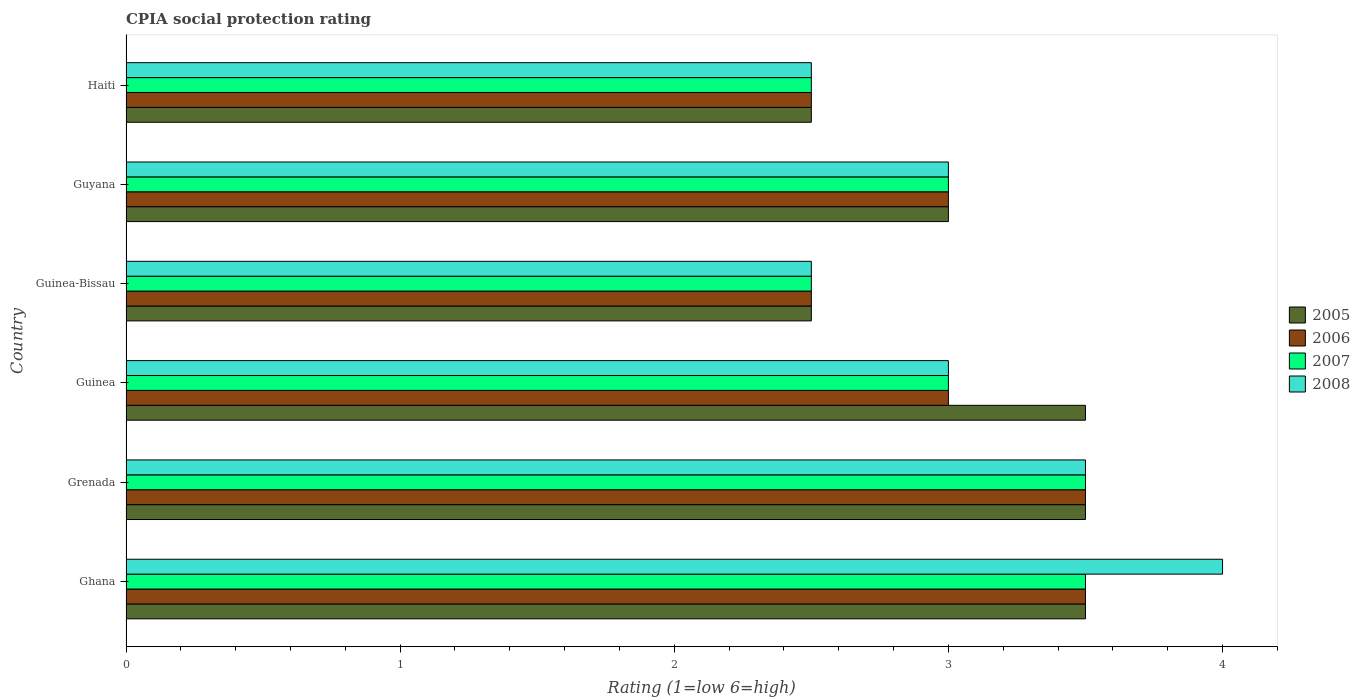How many different coloured bars are there?
Offer a very short reply. 4. How many groups of bars are there?
Your response must be concise. 6. Are the number of bars on each tick of the Y-axis equal?
Keep it short and to the point. Yes. How many bars are there on the 2nd tick from the top?
Your response must be concise. 4. How many bars are there on the 5th tick from the bottom?
Ensure brevity in your answer.  4. What is the label of the 4th group of bars from the top?
Keep it short and to the point. Guinea. What is the CPIA rating in 2005 in Guinea-Bissau?
Provide a succinct answer. 2.5. In which country was the CPIA rating in 2006 maximum?
Ensure brevity in your answer.  Ghana. In which country was the CPIA rating in 2007 minimum?
Keep it short and to the point. Guinea-Bissau. What is the difference between the CPIA rating in 2008 and CPIA rating in 2006 in Guinea?
Ensure brevity in your answer.  0. What is the ratio of the CPIA rating in 2006 in Ghana to that in Guinea?
Ensure brevity in your answer.  1.17. Is the CPIA rating in 2005 in Guinea less than that in Guyana?
Provide a succinct answer. No. Is the difference between the CPIA rating in 2008 in Grenada and Haiti greater than the difference between the CPIA rating in 2006 in Grenada and Haiti?
Your response must be concise. No. What is the difference between the highest and the second highest CPIA rating in 2005?
Your answer should be very brief. 0. What is the difference between the highest and the lowest CPIA rating in 2005?
Ensure brevity in your answer.  1. In how many countries, is the CPIA rating in 2005 greater than the average CPIA rating in 2005 taken over all countries?
Your answer should be compact. 3. Is the sum of the CPIA rating in 2008 in Guinea and Guinea-Bissau greater than the maximum CPIA rating in 2007 across all countries?
Your answer should be compact. Yes. What does the 1st bar from the top in Grenada represents?
Offer a terse response. 2008. How many bars are there?
Your answer should be very brief. 24. Are all the bars in the graph horizontal?
Your answer should be compact. Yes. Are the values on the major ticks of X-axis written in scientific E-notation?
Make the answer very short. No. Does the graph contain any zero values?
Your answer should be compact. No. Where does the legend appear in the graph?
Keep it short and to the point. Center right. What is the title of the graph?
Your answer should be compact. CPIA social protection rating. What is the label or title of the X-axis?
Ensure brevity in your answer.  Rating (1=low 6=high). What is the label or title of the Y-axis?
Ensure brevity in your answer.  Country. What is the Rating (1=low 6=high) of 2005 in Ghana?
Your answer should be compact. 3.5. What is the Rating (1=low 6=high) in 2006 in Ghana?
Provide a short and direct response. 3.5. What is the Rating (1=low 6=high) in 2006 in Grenada?
Provide a short and direct response. 3.5. What is the Rating (1=low 6=high) of 2008 in Grenada?
Your response must be concise. 3.5. What is the Rating (1=low 6=high) in 2005 in Guinea?
Your answer should be compact. 3.5. What is the Rating (1=low 6=high) of 2007 in Guinea?
Make the answer very short. 3. What is the Rating (1=low 6=high) in 2005 in Guinea-Bissau?
Make the answer very short. 2.5. What is the Rating (1=low 6=high) in 2007 in Guinea-Bissau?
Keep it short and to the point. 2.5. What is the Rating (1=low 6=high) of 2008 in Guinea-Bissau?
Give a very brief answer. 2.5. What is the Rating (1=low 6=high) in 2005 in Guyana?
Your answer should be compact. 3. What is the Rating (1=low 6=high) of 2006 in Haiti?
Give a very brief answer. 2.5. What is the Rating (1=low 6=high) of 2007 in Haiti?
Provide a short and direct response. 2.5. What is the Rating (1=low 6=high) of 2008 in Haiti?
Ensure brevity in your answer.  2.5. Across all countries, what is the maximum Rating (1=low 6=high) of 2005?
Make the answer very short. 3.5. Across all countries, what is the maximum Rating (1=low 6=high) of 2007?
Your answer should be compact. 3.5. Across all countries, what is the maximum Rating (1=low 6=high) of 2008?
Your response must be concise. 4. Across all countries, what is the minimum Rating (1=low 6=high) in 2005?
Ensure brevity in your answer.  2.5. Across all countries, what is the minimum Rating (1=low 6=high) in 2007?
Your response must be concise. 2.5. Across all countries, what is the minimum Rating (1=low 6=high) of 2008?
Offer a terse response. 2.5. What is the difference between the Rating (1=low 6=high) in 2005 in Ghana and that in Grenada?
Give a very brief answer. 0. What is the difference between the Rating (1=low 6=high) in 2007 in Ghana and that in Grenada?
Ensure brevity in your answer.  0. What is the difference between the Rating (1=low 6=high) in 2005 in Ghana and that in Guinea?
Keep it short and to the point. 0. What is the difference between the Rating (1=low 6=high) in 2008 in Ghana and that in Guinea?
Your answer should be very brief. 1. What is the difference between the Rating (1=low 6=high) of 2006 in Ghana and that in Guyana?
Ensure brevity in your answer.  0.5. What is the difference between the Rating (1=low 6=high) of 2005 in Ghana and that in Haiti?
Provide a short and direct response. 1. What is the difference between the Rating (1=low 6=high) of 2006 in Ghana and that in Haiti?
Your answer should be compact. 1. What is the difference between the Rating (1=low 6=high) in 2006 in Grenada and that in Guinea?
Your answer should be compact. 0.5. What is the difference between the Rating (1=low 6=high) of 2008 in Grenada and that in Guinea?
Keep it short and to the point. 0.5. What is the difference between the Rating (1=low 6=high) in 2008 in Grenada and that in Guinea-Bissau?
Keep it short and to the point. 1. What is the difference between the Rating (1=low 6=high) of 2006 in Grenada and that in Guyana?
Your answer should be very brief. 0.5. What is the difference between the Rating (1=low 6=high) in 2006 in Grenada and that in Haiti?
Your answer should be compact. 1. What is the difference between the Rating (1=low 6=high) in 2007 in Grenada and that in Haiti?
Offer a terse response. 1. What is the difference between the Rating (1=low 6=high) of 2007 in Guinea and that in Guinea-Bissau?
Offer a terse response. 0.5. What is the difference between the Rating (1=low 6=high) of 2007 in Guinea and that in Guyana?
Ensure brevity in your answer.  0. What is the difference between the Rating (1=low 6=high) in 2008 in Guinea and that in Guyana?
Offer a terse response. 0. What is the difference between the Rating (1=low 6=high) in 2005 in Guinea and that in Haiti?
Your answer should be very brief. 1. What is the difference between the Rating (1=low 6=high) in 2007 in Guinea and that in Haiti?
Offer a terse response. 0.5. What is the difference between the Rating (1=low 6=high) of 2005 in Guinea-Bissau and that in Guyana?
Provide a short and direct response. -0.5. What is the difference between the Rating (1=low 6=high) in 2007 in Guinea-Bissau and that in Guyana?
Ensure brevity in your answer.  -0.5. What is the difference between the Rating (1=low 6=high) of 2005 in Guinea-Bissau and that in Haiti?
Offer a terse response. 0. What is the difference between the Rating (1=low 6=high) of 2007 in Guinea-Bissau and that in Haiti?
Provide a succinct answer. 0. What is the difference between the Rating (1=low 6=high) of 2007 in Guyana and that in Haiti?
Keep it short and to the point. 0.5. What is the difference between the Rating (1=low 6=high) in 2008 in Guyana and that in Haiti?
Offer a terse response. 0.5. What is the difference between the Rating (1=low 6=high) in 2005 in Ghana and the Rating (1=low 6=high) in 2007 in Grenada?
Keep it short and to the point. 0. What is the difference between the Rating (1=low 6=high) of 2006 in Ghana and the Rating (1=low 6=high) of 2007 in Grenada?
Your answer should be compact. 0. What is the difference between the Rating (1=low 6=high) of 2007 in Ghana and the Rating (1=low 6=high) of 2008 in Grenada?
Keep it short and to the point. 0. What is the difference between the Rating (1=low 6=high) of 2005 in Ghana and the Rating (1=low 6=high) of 2007 in Guinea?
Offer a very short reply. 0.5. What is the difference between the Rating (1=low 6=high) in 2005 in Ghana and the Rating (1=low 6=high) in 2008 in Guinea?
Your answer should be very brief. 0.5. What is the difference between the Rating (1=low 6=high) in 2007 in Ghana and the Rating (1=low 6=high) in 2008 in Guinea?
Provide a succinct answer. 0.5. What is the difference between the Rating (1=low 6=high) in 2006 in Ghana and the Rating (1=low 6=high) in 2007 in Guinea-Bissau?
Provide a short and direct response. 1. What is the difference between the Rating (1=low 6=high) of 2006 in Ghana and the Rating (1=low 6=high) of 2008 in Guinea-Bissau?
Provide a short and direct response. 1. What is the difference between the Rating (1=low 6=high) in 2007 in Ghana and the Rating (1=low 6=high) in 2008 in Guinea-Bissau?
Provide a succinct answer. 1. What is the difference between the Rating (1=low 6=high) in 2006 in Ghana and the Rating (1=low 6=high) in 2008 in Guyana?
Your answer should be compact. 0.5. What is the difference between the Rating (1=low 6=high) of 2007 in Ghana and the Rating (1=low 6=high) of 2008 in Guyana?
Keep it short and to the point. 0.5. What is the difference between the Rating (1=low 6=high) of 2005 in Ghana and the Rating (1=low 6=high) of 2006 in Haiti?
Your answer should be compact. 1. What is the difference between the Rating (1=low 6=high) in 2005 in Ghana and the Rating (1=low 6=high) in 2008 in Haiti?
Ensure brevity in your answer.  1. What is the difference between the Rating (1=low 6=high) of 2005 in Grenada and the Rating (1=low 6=high) of 2006 in Guinea?
Your answer should be compact. 0.5. What is the difference between the Rating (1=low 6=high) of 2007 in Grenada and the Rating (1=low 6=high) of 2008 in Guinea?
Offer a terse response. 0.5. What is the difference between the Rating (1=low 6=high) in 2005 in Grenada and the Rating (1=low 6=high) in 2006 in Guinea-Bissau?
Provide a succinct answer. 1. What is the difference between the Rating (1=low 6=high) in 2005 in Grenada and the Rating (1=low 6=high) in 2008 in Guinea-Bissau?
Keep it short and to the point. 1. What is the difference between the Rating (1=low 6=high) in 2006 in Grenada and the Rating (1=low 6=high) in 2008 in Guinea-Bissau?
Ensure brevity in your answer.  1. What is the difference between the Rating (1=low 6=high) of 2005 in Grenada and the Rating (1=low 6=high) of 2006 in Guyana?
Keep it short and to the point. 0.5. What is the difference between the Rating (1=low 6=high) of 2005 in Grenada and the Rating (1=low 6=high) of 2007 in Guyana?
Give a very brief answer. 0.5. What is the difference between the Rating (1=low 6=high) in 2006 in Grenada and the Rating (1=low 6=high) in 2008 in Guyana?
Your answer should be very brief. 0.5. What is the difference between the Rating (1=low 6=high) of 2005 in Grenada and the Rating (1=low 6=high) of 2006 in Haiti?
Make the answer very short. 1. What is the difference between the Rating (1=low 6=high) of 2005 in Grenada and the Rating (1=low 6=high) of 2008 in Haiti?
Offer a very short reply. 1. What is the difference between the Rating (1=low 6=high) in 2006 in Grenada and the Rating (1=low 6=high) in 2008 in Haiti?
Ensure brevity in your answer.  1. What is the difference between the Rating (1=low 6=high) of 2007 in Grenada and the Rating (1=low 6=high) of 2008 in Haiti?
Your answer should be compact. 1. What is the difference between the Rating (1=low 6=high) in 2005 in Guinea and the Rating (1=low 6=high) in 2006 in Guinea-Bissau?
Provide a short and direct response. 1. What is the difference between the Rating (1=low 6=high) in 2005 in Guinea and the Rating (1=low 6=high) in 2008 in Guinea-Bissau?
Provide a short and direct response. 1. What is the difference between the Rating (1=low 6=high) in 2006 in Guinea and the Rating (1=low 6=high) in 2008 in Guinea-Bissau?
Your answer should be compact. 0.5. What is the difference between the Rating (1=low 6=high) in 2005 in Guinea and the Rating (1=low 6=high) in 2006 in Guyana?
Keep it short and to the point. 0.5. What is the difference between the Rating (1=low 6=high) in 2005 in Guinea and the Rating (1=low 6=high) in 2007 in Guyana?
Offer a terse response. 0.5. What is the difference between the Rating (1=low 6=high) of 2006 in Guinea and the Rating (1=low 6=high) of 2008 in Guyana?
Ensure brevity in your answer.  0. What is the difference between the Rating (1=low 6=high) of 2007 in Guinea and the Rating (1=low 6=high) of 2008 in Guyana?
Give a very brief answer. 0. What is the difference between the Rating (1=low 6=high) in 2005 in Guinea and the Rating (1=low 6=high) in 2006 in Haiti?
Offer a very short reply. 1. What is the difference between the Rating (1=low 6=high) in 2005 in Guinea and the Rating (1=low 6=high) in 2007 in Haiti?
Give a very brief answer. 1. What is the difference between the Rating (1=low 6=high) of 2006 in Guinea and the Rating (1=low 6=high) of 2007 in Haiti?
Offer a very short reply. 0.5. What is the difference between the Rating (1=low 6=high) of 2007 in Guinea and the Rating (1=low 6=high) of 2008 in Haiti?
Provide a short and direct response. 0.5. What is the difference between the Rating (1=low 6=high) in 2005 in Guinea-Bissau and the Rating (1=low 6=high) in 2007 in Guyana?
Your answer should be very brief. -0.5. What is the difference between the Rating (1=low 6=high) in 2005 in Guinea-Bissau and the Rating (1=low 6=high) in 2006 in Haiti?
Provide a succinct answer. 0. What is the difference between the Rating (1=low 6=high) in 2005 in Guyana and the Rating (1=low 6=high) in 2007 in Haiti?
Provide a succinct answer. 0.5. What is the difference between the Rating (1=low 6=high) in 2005 in Guyana and the Rating (1=low 6=high) in 2008 in Haiti?
Your answer should be compact. 0.5. What is the difference between the Rating (1=low 6=high) of 2006 in Guyana and the Rating (1=low 6=high) of 2007 in Haiti?
Provide a succinct answer. 0.5. What is the average Rating (1=low 6=high) of 2005 per country?
Ensure brevity in your answer.  3.08. What is the average Rating (1=low 6=high) in 2008 per country?
Provide a short and direct response. 3.08. What is the difference between the Rating (1=low 6=high) in 2005 and Rating (1=low 6=high) in 2007 in Ghana?
Your response must be concise. 0. What is the difference between the Rating (1=low 6=high) in 2005 and Rating (1=low 6=high) in 2008 in Ghana?
Your answer should be compact. -0.5. What is the difference between the Rating (1=low 6=high) in 2006 and Rating (1=low 6=high) in 2007 in Ghana?
Offer a terse response. 0. What is the difference between the Rating (1=low 6=high) in 2007 and Rating (1=low 6=high) in 2008 in Ghana?
Provide a succinct answer. -0.5. What is the difference between the Rating (1=low 6=high) of 2005 and Rating (1=low 6=high) of 2008 in Grenada?
Ensure brevity in your answer.  0. What is the difference between the Rating (1=low 6=high) of 2006 and Rating (1=low 6=high) of 2007 in Grenada?
Offer a terse response. 0. What is the difference between the Rating (1=low 6=high) of 2007 and Rating (1=low 6=high) of 2008 in Grenada?
Provide a short and direct response. 0. What is the difference between the Rating (1=low 6=high) in 2005 and Rating (1=low 6=high) in 2008 in Guinea?
Keep it short and to the point. 0.5. What is the difference between the Rating (1=low 6=high) in 2006 and Rating (1=low 6=high) in 2007 in Guinea?
Provide a succinct answer. 0. What is the difference between the Rating (1=low 6=high) in 2006 and Rating (1=low 6=high) in 2007 in Guinea-Bissau?
Keep it short and to the point. 0. What is the difference between the Rating (1=low 6=high) in 2005 and Rating (1=low 6=high) in 2007 in Guyana?
Your answer should be very brief. 0. What is the difference between the Rating (1=low 6=high) of 2006 and Rating (1=low 6=high) of 2007 in Guyana?
Keep it short and to the point. 0. What is the difference between the Rating (1=low 6=high) of 2006 and Rating (1=low 6=high) of 2008 in Guyana?
Provide a short and direct response. 0. What is the difference between the Rating (1=low 6=high) in 2005 and Rating (1=low 6=high) in 2006 in Haiti?
Provide a short and direct response. 0. What is the difference between the Rating (1=low 6=high) of 2005 and Rating (1=low 6=high) of 2008 in Haiti?
Your answer should be very brief. 0. What is the difference between the Rating (1=low 6=high) in 2006 and Rating (1=low 6=high) in 2008 in Haiti?
Your response must be concise. 0. What is the ratio of the Rating (1=low 6=high) in 2006 in Ghana to that in Grenada?
Give a very brief answer. 1. What is the ratio of the Rating (1=low 6=high) in 2008 in Ghana to that in Grenada?
Provide a short and direct response. 1.14. What is the ratio of the Rating (1=low 6=high) of 2005 in Ghana to that in Guinea?
Offer a very short reply. 1. What is the ratio of the Rating (1=low 6=high) of 2006 in Ghana to that in Guinea?
Offer a terse response. 1.17. What is the ratio of the Rating (1=low 6=high) in 2007 in Ghana to that in Guinea?
Make the answer very short. 1.17. What is the ratio of the Rating (1=low 6=high) in 2008 in Ghana to that in Guinea?
Offer a very short reply. 1.33. What is the ratio of the Rating (1=low 6=high) in 2005 in Ghana to that in Guinea-Bissau?
Offer a terse response. 1.4. What is the ratio of the Rating (1=low 6=high) in 2005 in Ghana to that in Guyana?
Ensure brevity in your answer.  1.17. What is the ratio of the Rating (1=low 6=high) of 2008 in Ghana to that in Guyana?
Offer a terse response. 1.33. What is the ratio of the Rating (1=low 6=high) in 2005 in Ghana to that in Haiti?
Give a very brief answer. 1.4. What is the ratio of the Rating (1=low 6=high) of 2007 in Ghana to that in Haiti?
Provide a short and direct response. 1.4. What is the ratio of the Rating (1=low 6=high) of 2005 in Grenada to that in Guinea?
Offer a very short reply. 1. What is the ratio of the Rating (1=low 6=high) of 2006 in Grenada to that in Guinea?
Offer a very short reply. 1.17. What is the ratio of the Rating (1=low 6=high) of 2007 in Grenada to that in Guinea?
Your answer should be compact. 1.17. What is the ratio of the Rating (1=low 6=high) of 2008 in Grenada to that in Guinea?
Provide a short and direct response. 1.17. What is the ratio of the Rating (1=low 6=high) of 2005 in Grenada to that in Guinea-Bissau?
Offer a terse response. 1.4. What is the ratio of the Rating (1=low 6=high) of 2006 in Grenada to that in Guinea-Bissau?
Make the answer very short. 1.4. What is the ratio of the Rating (1=low 6=high) of 2007 in Grenada to that in Guinea-Bissau?
Your response must be concise. 1.4. What is the ratio of the Rating (1=low 6=high) in 2008 in Grenada to that in Guinea-Bissau?
Your response must be concise. 1.4. What is the ratio of the Rating (1=low 6=high) in 2006 in Grenada to that in Guyana?
Keep it short and to the point. 1.17. What is the ratio of the Rating (1=low 6=high) in 2006 in Grenada to that in Haiti?
Give a very brief answer. 1.4. What is the ratio of the Rating (1=low 6=high) in 2008 in Grenada to that in Haiti?
Your answer should be very brief. 1.4. What is the ratio of the Rating (1=low 6=high) in 2005 in Guinea to that in Guinea-Bissau?
Your response must be concise. 1.4. What is the ratio of the Rating (1=low 6=high) in 2007 in Guinea to that in Guinea-Bissau?
Your answer should be very brief. 1.2. What is the ratio of the Rating (1=low 6=high) of 2008 in Guinea to that in Guinea-Bissau?
Your answer should be very brief. 1.2. What is the ratio of the Rating (1=low 6=high) in 2005 in Guinea to that in Guyana?
Provide a short and direct response. 1.17. What is the ratio of the Rating (1=low 6=high) of 2008 in Guinea to that in Guyana?
Keep it short and to the point. 1. What is the ratio of the Rating (1=low 6=high) in 2005 in Guinea to that in Haiti?
Your answer should be very brief. 1.4. What is the ratio of the Rating (1=low 6=high) in 2006 in Guinea-Bissau to that in Guyana?
Ensure brevity in your answer.  0.83. What is the ratio of the Rating (1=low 6=high) in 2007 in Guinea-Bissau to that in Guyana?
Your response must be concise. 0.83. What is the ratio of the Rating (1=low 6=high) in 2008 in Guinea-Bissau to that in Guyana?
Your response must be concise. 0.83. What is the ratio of the Rating (1=low 6=high) of 2005 in Guinea-Bissau to that in Haiti?
Keep it short and to the point. 1. What is the ratio of the Rating (1=low 6=high) of 2007 in Guinea-Bissau to that in Haiti?
Your answer should be compact. 1. What is the ratio of the Rating (1=low 6=high) of 2008 in Guinea-Bissau to that in Haiti?
Your response must be concise. 1. What is the ratio of the Rating (1=low 6=high) in 2005 in Guyana to that in Haiti?
Give a very brief answer. 1.2. What is the ratio of the Rating (1=low 6=high) in 2006 in Guyana to that in Haiti?
Provide a short and direct response. 1.2. What is the ratio of the Rating (1=low 6=high) of 2007 in Guyana to that in Haiti?
Offer a terse response. 1.2. What is the ratio of the Rating (1=low 6=high) of 2008 in Guyana to that in Haiti?
Your answer should be very brief. 1.2. What is the difference between the highest and the second highest Rating (1=low 6=high) in 2005?
Your answer should be very brief. 0. What is the difference between the highest and the second highest Rating (1=low 6=high) in 2006?
Offer a very short reply. 0. What is the difference between the highest and the lowest Rating (1=low 6=high) in 2005?
Ensure brevity in your answer.  1. What is the difference between the highest and the lowest Rating (1=low 6=high) of 2007?
Provide a succinct answer. 1. What is the difference between the highest and the lowest Rating (1=low 6=high) in 2008?
Keep it short and to the point. 1.5. 